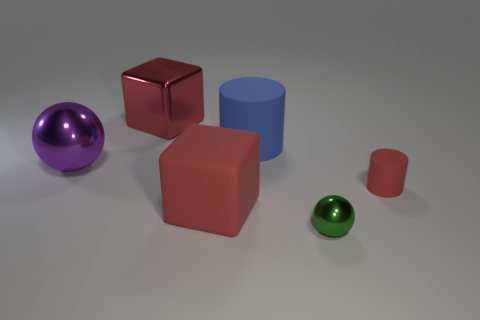Add 2 big matte cylinders. How many objects exist? 8 Subtract all red cylinders. How many cylinders are left? 1 Subtract all green balls. Subtract all blue cubes. How many balls are left? 1 Subtract all red cylinders. How many green balls are left? 1 Subtract all large metal blocks. Subtract all small red rubber objects. How many objects are left? 4 Add 4 blocks. How many blocks are left? 6 Add 4 tiny balls. How many tiny balls exist? 5 Subtract 0 cyan balls. How many objects are left? 6 Subtract all spheres. How many objects are left? 4 Subtract 2 spheres. How many spheres are left? 0 